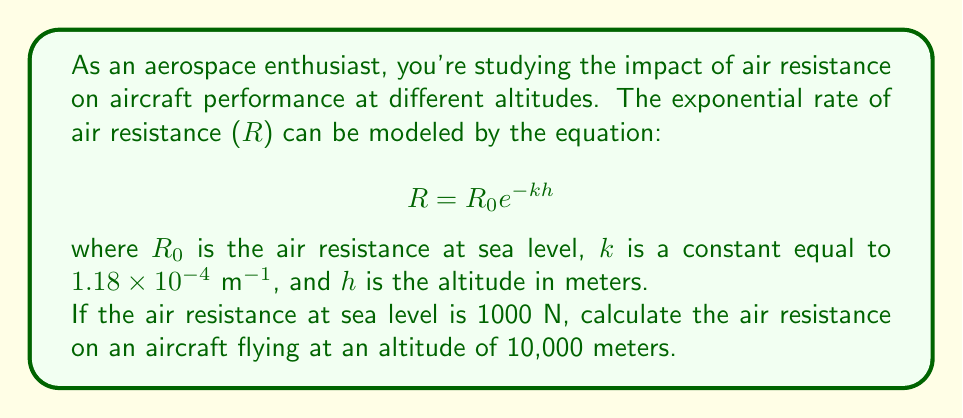Teach me how to tackle this problem. To solve this problem, we'll use the given equation and substitute the known values:

1. Given:
   - $R_0 = 1000 \text{ N}$ (air resistance at sea level)
   - $k = 1.18 \times 10^{-4} \text{ m}^{-1}$
   - $h = 10,000 \text{ m}$ (altitude)

2. Substitute these values into the equation:
   $$R = R_0 e^{-kh}$$
   $$R = 1000 \cdot e^{-(1.18 \times 10^{-4}) \cdot 10000}$$

3. Simplify the exponent:
   $$R = 1000 \cdot e^{-1.18}$$

4. Calculate the value of $e^{-1.18}$ using a calculator:
   $$e^{-1.18} \approx 0.3074$$

5. Multiply by 1000:
   $$R = 1000 \cdot 0.3074 = 307.4 \text{ N}$$

Therefore, the air resistance on the aircraft at an altitude of 10,000 meters is approximately 307.4 N.
Answer: 307.4 N 